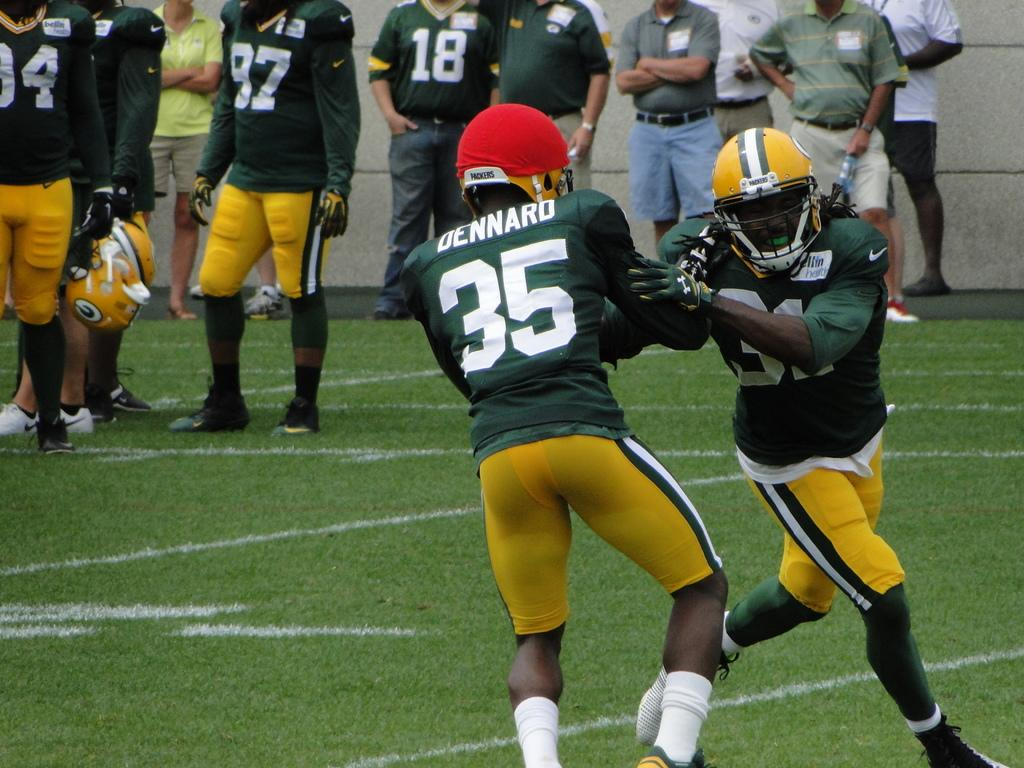How many people are in the image? There is a group of people in the image. Can you describe the attire of the two persons in the front? Two persons are in the front, wearing green and yellow color dresses. What can be seen in the background of the image? There is a wall in the background of the image, and it is gray in color. What type of box is being used by the team in the image? There is no box or team present in the image; it features a group of people with two persons in the front wearing green and yellow color dresses. 